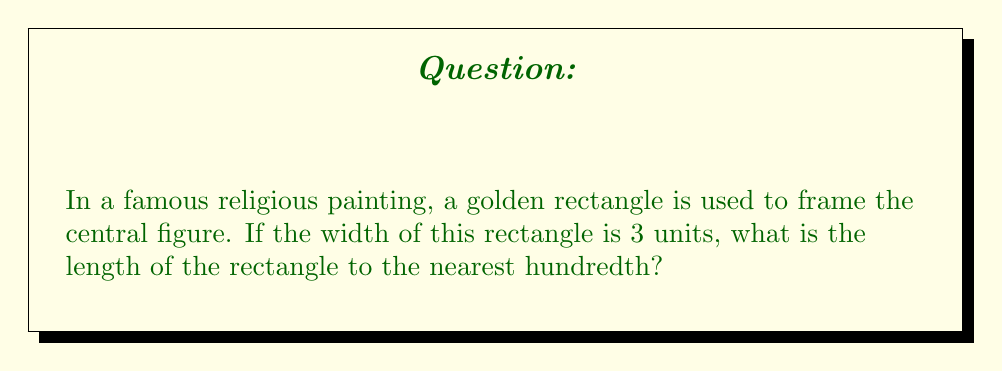Provide a solution to this math problem. Let's approach this step-by-step:

1) A golden rectangle has the property that the ratio of its length to its width is equal to the golden ratio, φ (phi).

2) The golden ratio is defined as:

   $$φ = \frac{1 + \sqrt{5}}{2}$$

3) Let's calculate the value of φ:
   
   $$φ = \frac{1 + \sqrt{5}}{2} ≈ 1.6180339887...$$

4) In a golden rectangle, if we denote the width as w and the length as l, we have:

   $$\frac{l}{w} = φ$$

5) We're given that the width is 3 units. So:

   $$\frac{l}{3} = φ$$

6) To find l, we multiply both sides by 3:

   $$l = 3φ$$

7) Substituting the value of φ:

   $$l = 3 * 1.6180339887...$$
   $$l = 4.8541019661...$$

8) Rounding to the nearest hundredth:

   $$l ≈ 4.85$$

Therefore, the length of the golden rectangle is approximately 4.85 units.
Answer: 4.85 units 